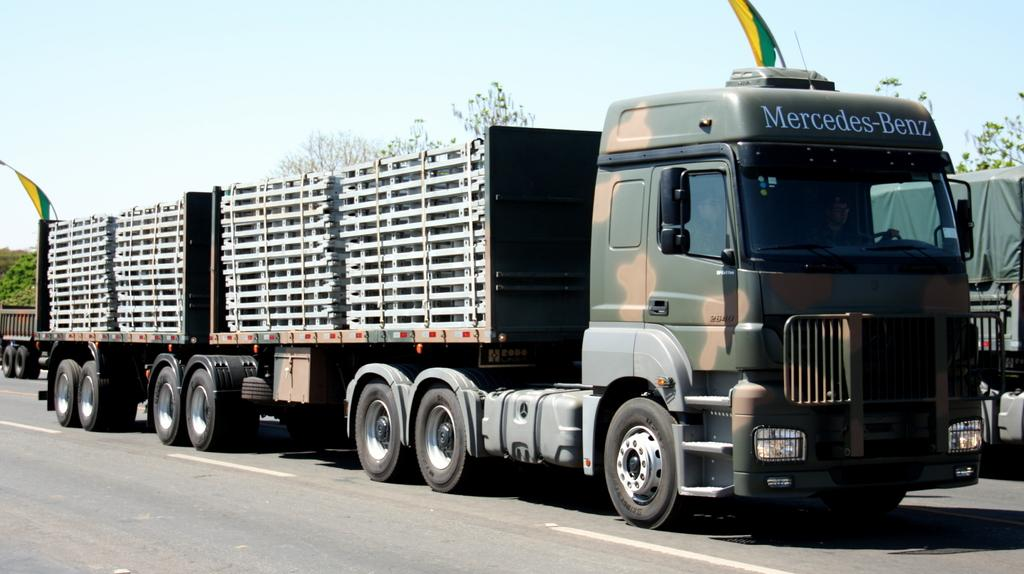What type of vehicle is in the image? There is a green color military lorry in the image. What is the lorry doing in the image? The lorry is passing on the road. What can be seen in the background of the image? There are many silver color metal frames in the background of the image. How many bells can be seen hanging from the neck of the lorry in the image? There are no bells visible in the image, nor is there any reference to a neck for the lorry. 